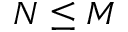Convert formula to latex. <formula><loc_0><loc_0><loc_500><loc_500>N \leq M</formula> 